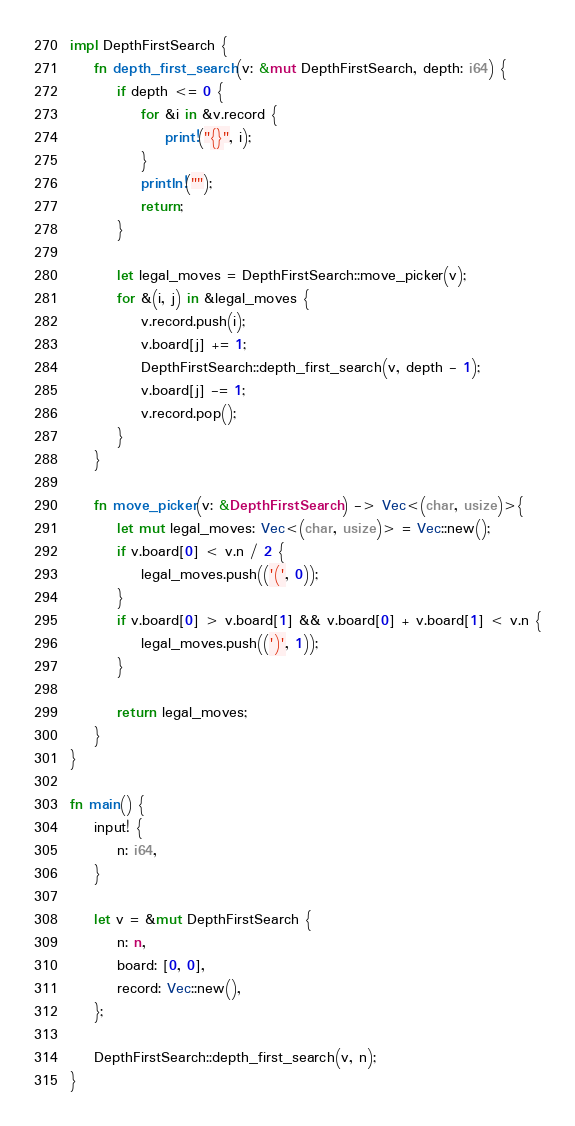<code> <loc_0><loc_0><loc_500><loc_500><_Rust_>
impl DepthFirstSearch {
    fn depth_first_search(v: &mut DepthFirstSearch, depth: i64) {
        if depth <= 0 {
            for &i in &v.record {
                print!("{}", i);
            }
            println!("");
            return;
        }

        let legal_moves = DepthFirstSearch::move_picker(v);
        for &(i, j) in &legal_moves {
            v.record.push(i);
            v.board[j] += 1;
            DepthFirstSearch::depth_first_search(v, depth - 1);
            v.board[j] -= 1;
            v.record.pop();
        }
    }

    fn move_picker(v: &DepthFirstSearch) -> Vec<(char, usize)>{
        let mut legal_moves: Vec<(char, usize)> = Vec::new();
        if v.board[0] < v.n / 2 {
            legal_moves.push(('(', 0));
        }
        if v.board[0] > v.board[1] && v.board[0] + v.board[1] < v.n {
            legal_moves.push((')', 1));
        }

        return legal_moves;
    }
}

fn main() {
    input! {
        n: i64,
    }
 
    let v = &mut DepthFirstSearch {
        n: n,
        board: [0, 0],
        record: Vec::new(),
    };
 
    DepthFirstSearch::depth_first_search(v, n);
}
</code> 